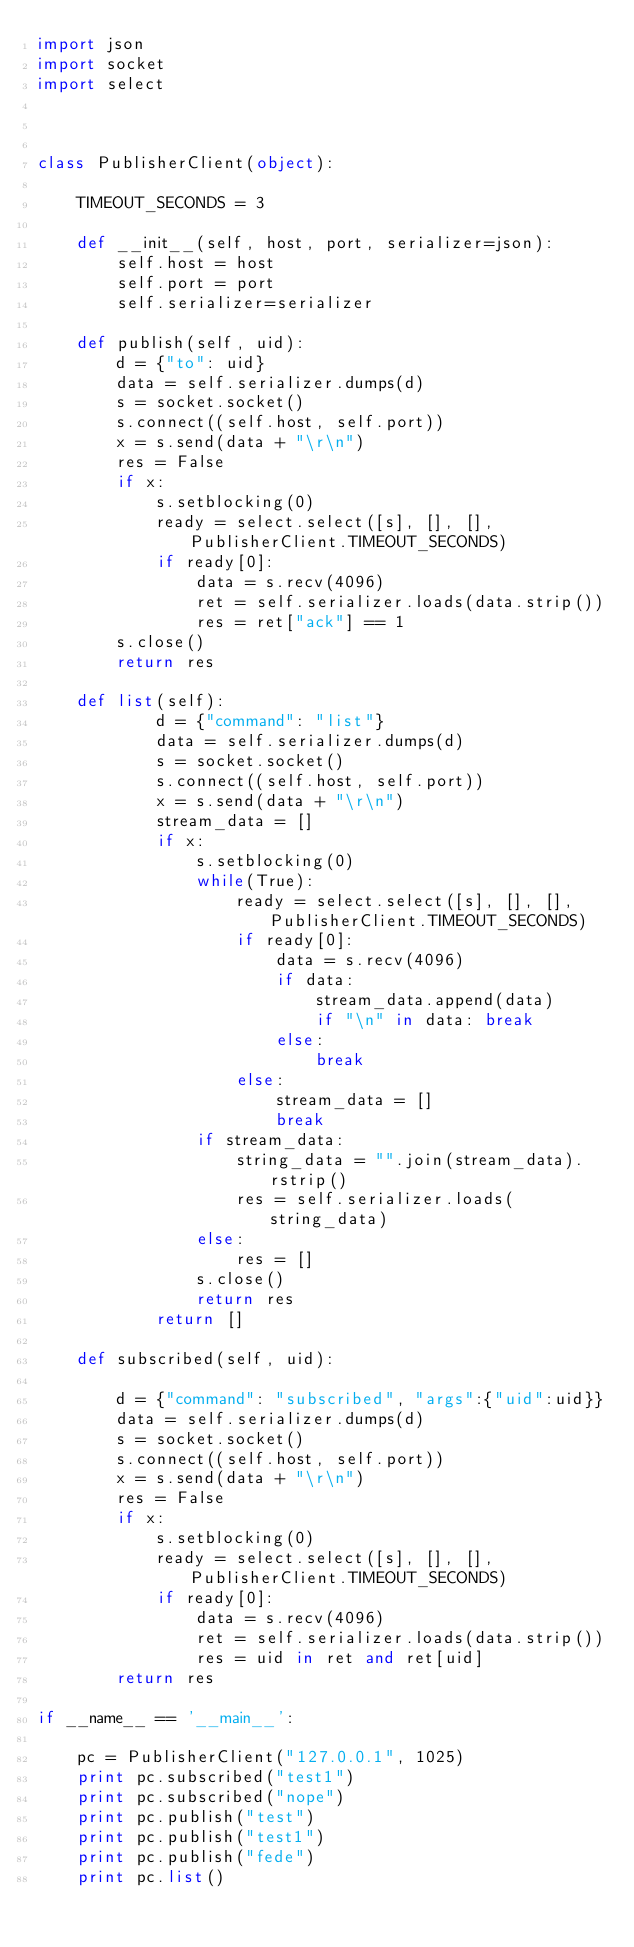Convert code to text. <code><loc_0><loc_0><loc_500><loc_500><_Python_>import json
import socket
import select



class PublisherClient(object):

    TIMEOUT_SECONDS = 3

    def __init__(self, host, port, serializer=json):
        self.host = host
        self.port = port
        self.serializer=serializer

    def publish(self, uid):
        d = {"to": uid}
        data = self.serializer.dumps(d)
        s = socket.socket()
        s.connect((self.host, self.port))
        x = s.send(data + "\r\n")
        res = False
        if x:
            s.setblocking(0)
            ready = select.select([s], [], [], PublisherClient.TIMEOUT_SECONDS)
            if ready[0]:
                data = s.recv(4096)
                ret = self.serializer.loads(data.strip())
                res = ret["ack"] == 1
        s.close()
        return res

    def list(self):
            d = {"command": "list"}
            data = self.serializer.dumps(d)
            s = socket.socket()
            s.connect((self.host, self.port))
            x = s.send(data + "\r\n")
            stream_data = []
            if x:
                s.setblocking(0)
                while(True):
                    ready = select.select([s], [], [], PublisherClient.TIMEOUT_SECONDS)
                    if ready[0]:
                        data = s.recv(4096)
                        if data:
                            stream_data.append(data)
                            if "\n" in data: break
                        else:
                            break
                    else:
                        stream_data = []
                        break
                if stream_data:
                    string_data = "".join(stream_data).rstrip()
                    res = self.serializer.loads(string_data)
                else:
                    res = []
                s.close()
                return res
            return []

    def subscribed(self, uid):

        d = {"command": "subscribed", "args":{"uid":uid}}
        data = self.serializer.dumps(d)
        s = socket.socket()
        s.connect((self.host, self.port))
        x = s.send(data + "\r\n")
        res = False
        if x:
            s.setblocking(0)
            ready = select.select([s], [], [], PublisherClient.TIMEOUT_SECONDS)
            if ready[0]:
                data = s.recv(4096)
                ret = self.serializer.loads(data.strip())
                res = uid in ret and ret[uid]
        return res

if __name__ == '__main__':

    pc = PublisherClient("127.0.0.1", 1025)
    print pc.subscribed("test1")
    print pc.subscribed("nope")
    print pc.publish("test")
    print pc.publish("test1")
    print pc.publish("fede")
    print pc.list()

</code> 